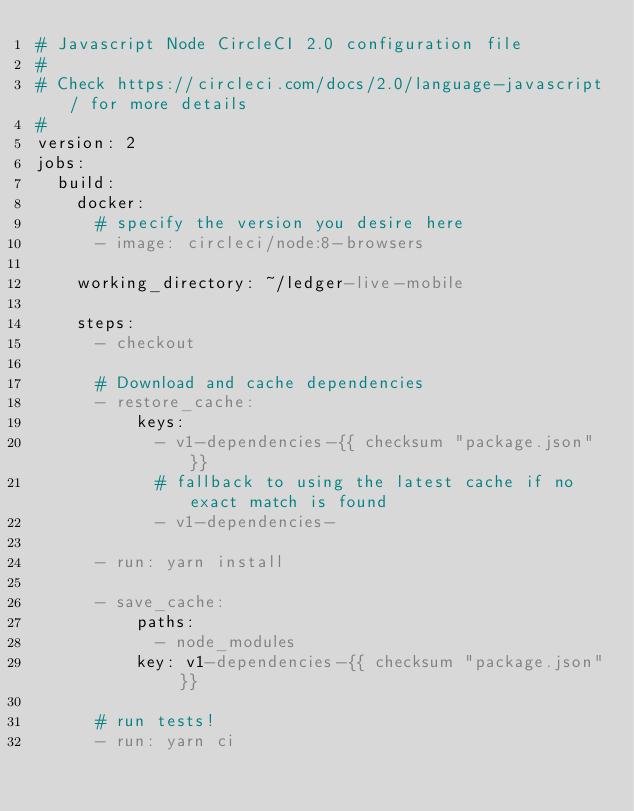Convert code to text. <code><loc_0><loc_0><loc_500><loc_500><_YAML_># Javascript Node CircleCI 2.0 configuration file
#
# Check https://circleci.com/docs/2.0/language-javascript/ for more details
#
version: 2
jobs:
  build:
    docker:
      # specify the version you desire here
      - image: circleci/node:8-browsers

    working_directory: ~/ledger-live-mobile

    steps:
      - checkout

      # Download and cache dependencies
      - restore_cache:
          keys:
            - v1-dependencies-{{ checksum "package.json" }}
            # fallback to using the latest cache if no exact match is found
            - v1-dependencies-

      - run: yarn install

      - save_cache:
          paths:
            - node_modules
          key: v1-dependencies-{{ checksum "package.json" }}

      # run tests!
      - run: yarn ci
</code> 